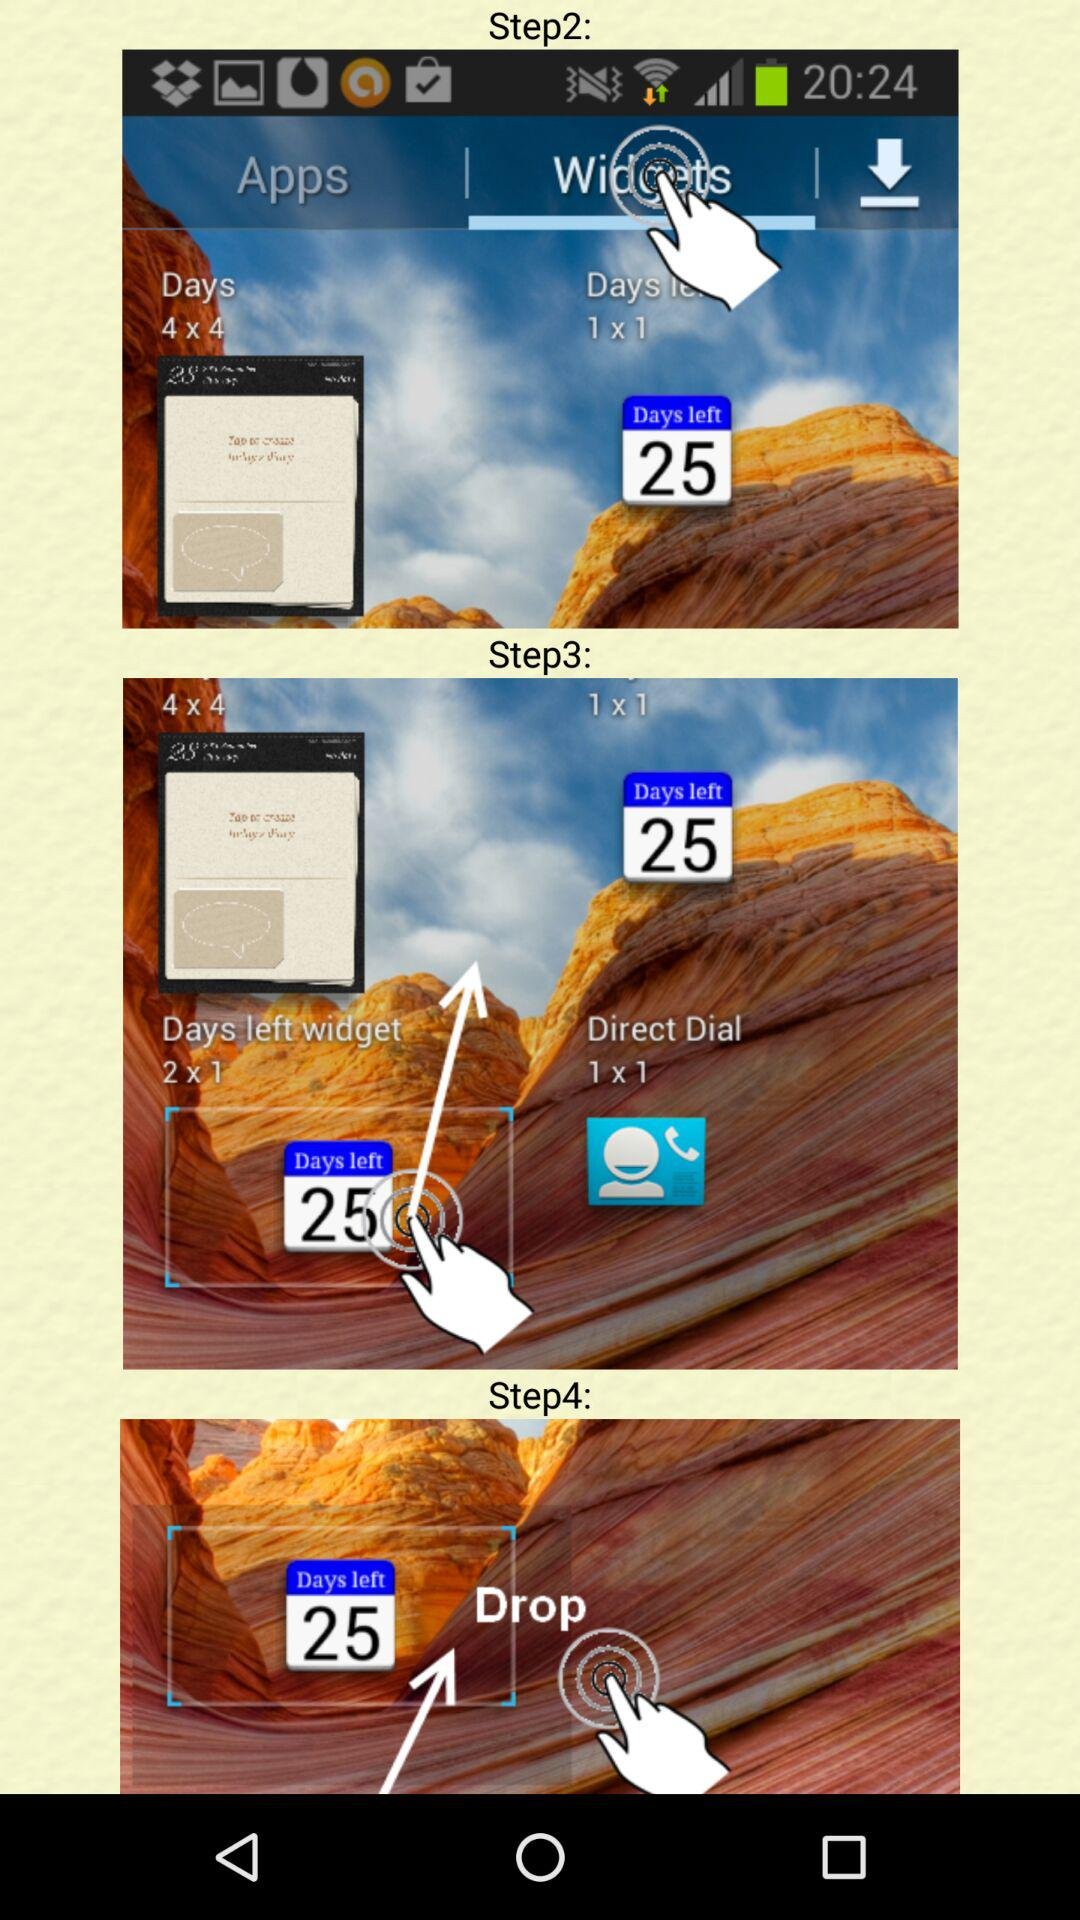Which tab is selected? The selected tab is "Widgets". 